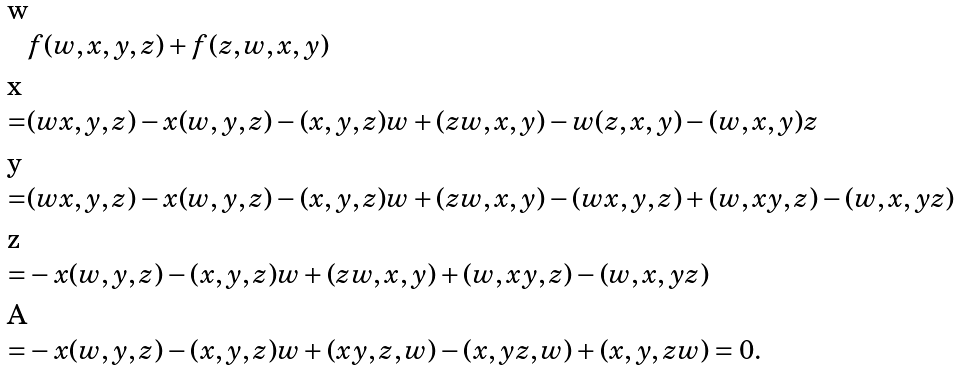<formula> <loc_0><loc_0><loc_500><loc_500>& f ( w , x , y , z ) + f ( z , w , x , y ) & \\ = & ( w x , y , z ) - x ( w , y , z ) - ( x , y , z ) w + ( z w , x , y ) - w ( z , x , y ) - ( w , x , y ) z & \\ = & ( w x , y , z ) - x ( w , y , z ) - ( x , y , z ) w + ( z w , x , y ) - ( w x , y , z ) + ( w , x y , z ) - ( w , x , y z ) & \\ = & - x ( w , y , z ) - ( x , y , z ) w + ( z w , x , y ) + ( w , x y , z ) - ( w , x , y z ) & \\ = & - x ( w , y , z ) - ( x , y , z ) w + ( x y , z , w ) - ( x , y z , w ) + ( x , y , z w ) = 0 . &</formula> 